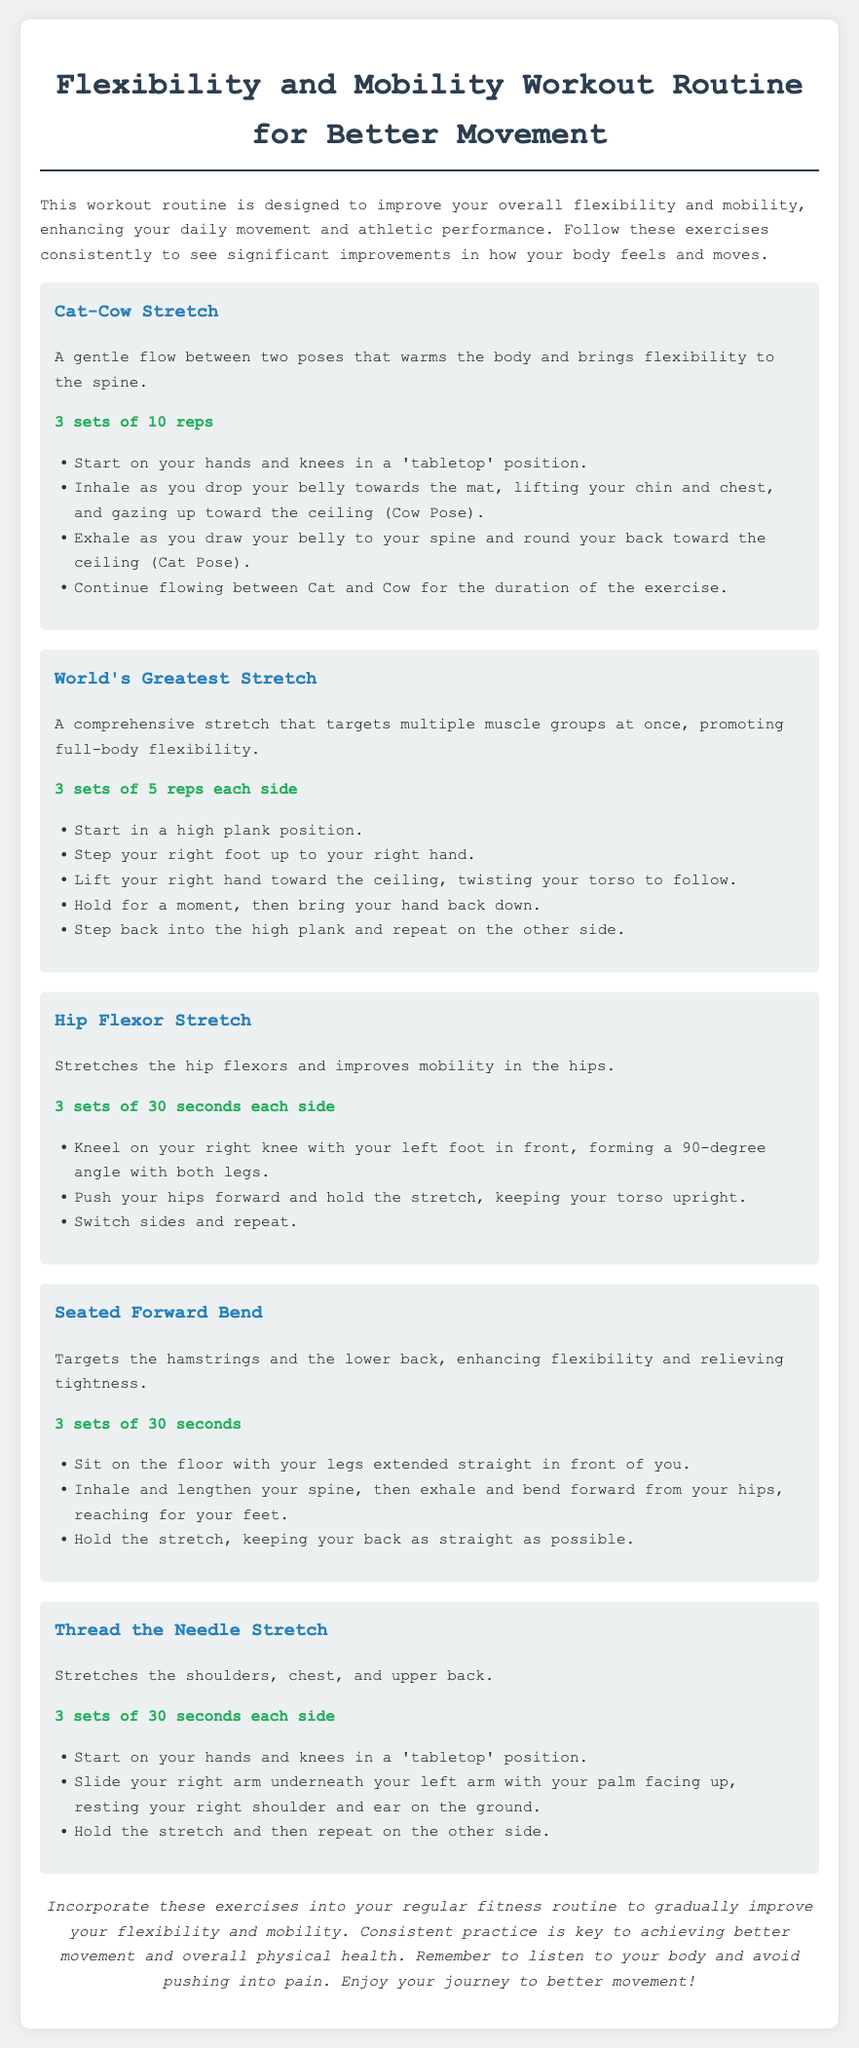What is the title of the workout plan? The title of the workout plan is presented in the document header as "Flexibility and Mobility Workout Routine for Better Movement."
Answer: Flexibility and Mobility Workout Routine for Better Movement How many sets are recommended for the Cat-Cow Stretch? The document specifies that the Cat-Cow Stretch should be performed for 3 sets of 10 reps.
Answer: 3 sets of 10 reps What primary area does the Hip Flexor Stretch target? The Hip Flexor Stretch is specifically mentioned to stretch the hip flexors and improve mobility in the hips.
Answer: Hip flexors How long should the Seated Forward Bend be held? The document indicates that the Seated Forward Bend should be held for 3 sets of 30 seconds.
Answer: 30 seconds Which stretch requires stepping back into a high plank position? The World's Greatest Stretch requires stepping back into a high plank position after each side is completed.
Answer: World's Greatest Stretch What is the purpose of these exercises according to the document? The document states that the purpose of the exercises is to improve flexibility and mobility, enhancing daily movement and athletic performance.
Answer: Improve flexibility and mobility How many repetitions are suggested for each side in the Thread the Needle Stretch? The document specifies that the Thread the Needle Stretch should be performed for 3 sets of 30 seconds each side.
Answer: 30 seconds each side Which exercise involves a tabletop position? The Cat-Cow Stretch and Thread the Needle Stretch both start in a tabletop position.
Answer: Cat-Cow Stretch, Thread the Needle Stretch What should you listen to during the workout? The conclusion emphasizes the importance of listening to your body while performing the exercises.
Answer: Your body 